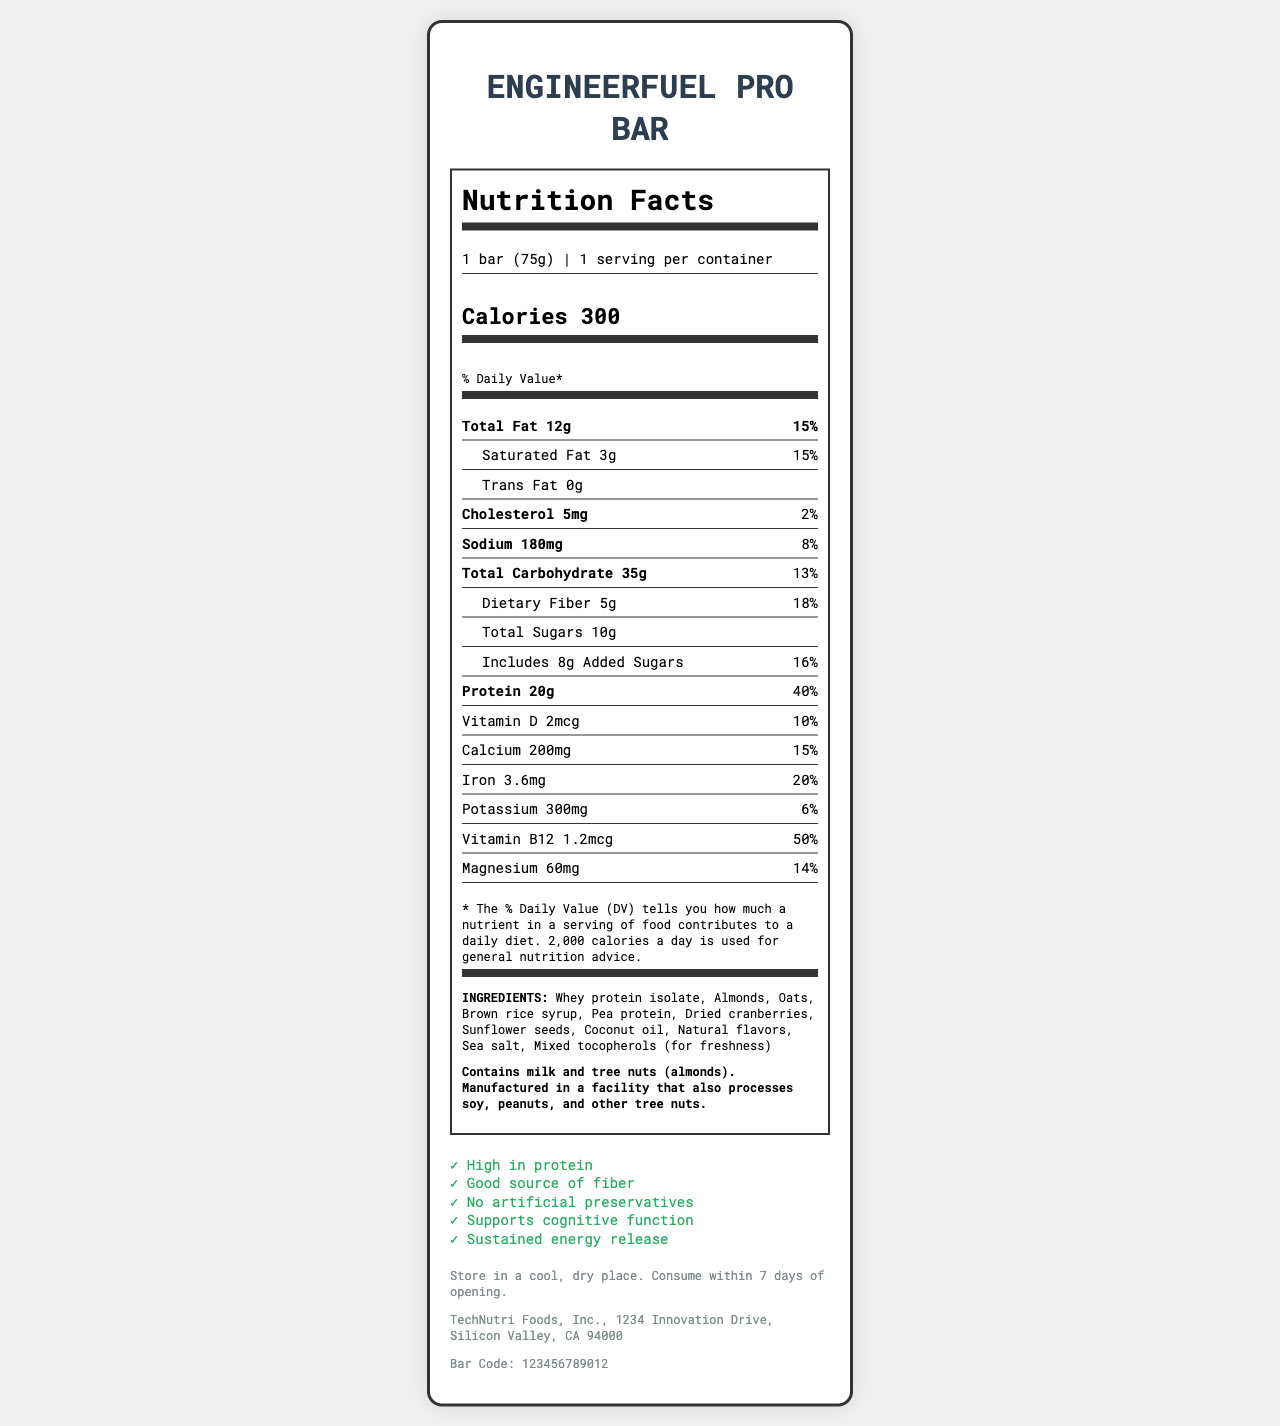what is the serving size? The serving size information is given at the top of the Nutrition Facts section: "1 bar (75g)".
Answer: 1 bar (75g) how many calories are there per serving? The calorie content is displayed prominently in the calorie information section: "Calories 300".
Answer: 300 what is the total fat content? The total fat amount is listed in the nutrient information section: "Total Fat 12g".
Answer: 12g how much protein is in one serving of the energy bar? The protein content is provided in the nutrient information section: "Protein 20g".
Answer: 20g which ingredient is listed first? Ingredient lists typically start with the ingredient used in the largest amount. The first ingredient listed here is "Whey protein isolate".
Answer: Whey protein isolate how many grams of dietary fiber are in one serving? The dietary fiber content is listed under the total carbohydrate section: "Dietary Fiber 5g".
Answer: 5g what is the percentage of daily value for calcium? The daily value for calcium is shown next to the calcium amount: "Calcium 200mg 15%".
Answer: 15% how much sodium does the energy bar contain? The sodium content is provided in the nutrient information section: "Sodium 180mg".
Answer: 180mg which vitamin has the highest percentage daily value? A. Vitamin D B. Calcium C. Iron D. Vitamin B12 The vitamin with the highest percentage daily value is Vitamin B12 at "50%".
Answer: D. Vitamin B12 what claims are made about this product? A. High in protein B. Good source of vitamins C. No artificial preservatives D. Supports cognitive function Claims made about the product can be seen in the claims section: "High in protein, No artificial preservatives, Supports cognitive function".
Answer: A, C, D is the energy bar suitable for those with tree nut allergies? The allergen information states: "Contains milk and tree nuts (almonds)".
Answer: No what is the main idea of the document? The document is a Nutrition Facts Label for the EngineerFuel Pro Bar, showcasing its nutritional content, ingredients, allergens, claims, and additional product information.
Answer: It provides detailed nutritional information about the EngineerFuel Pro Bar, a high-protein energy bar designed for engineers working long hours. The document includes serving size, calories, macro and micronutrient content, ingredient list, allergen information, product claims, storage instructions, and manufacturer details. how much vitamin C does the energy bar contain? The document does not provide any information on the vitamin C content of the energy bar.
Answer: Not enough information 